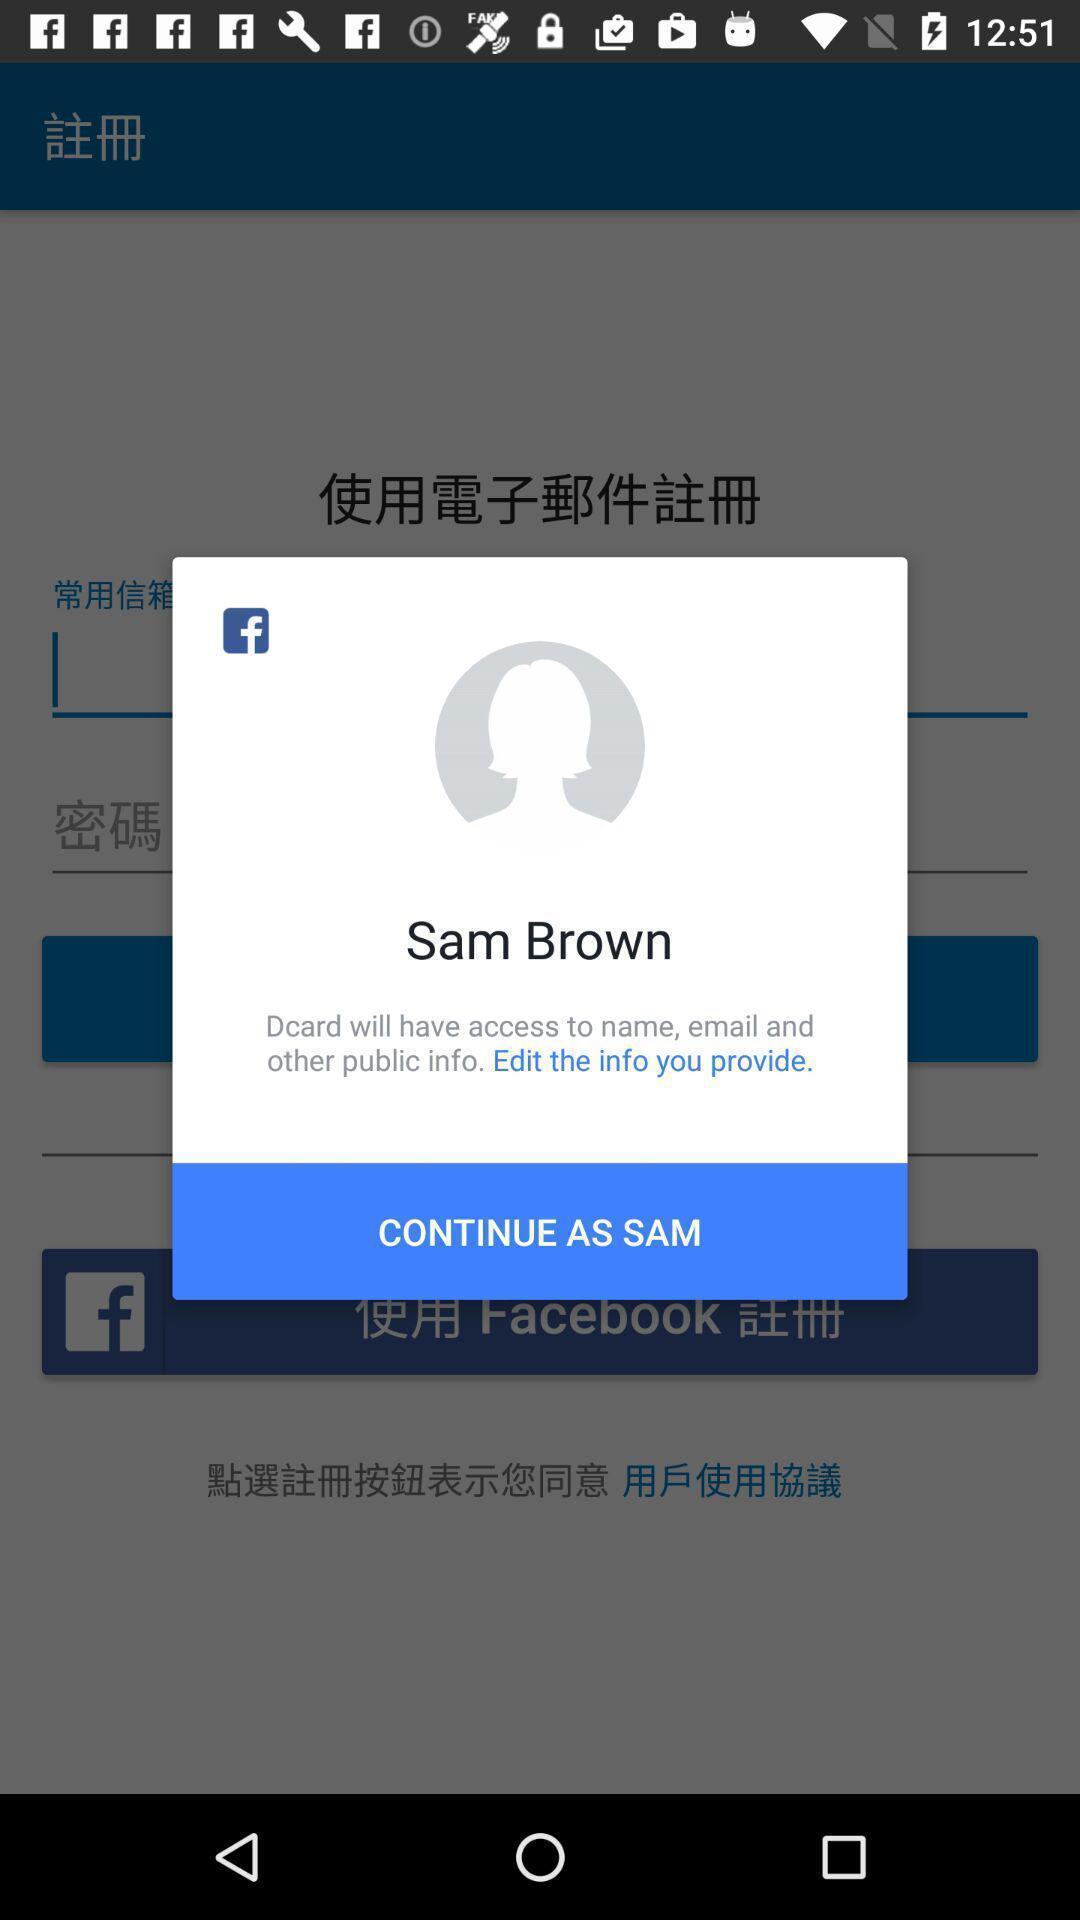Provide a detailed account of this screenshot. Pop-up to continue in social app. 